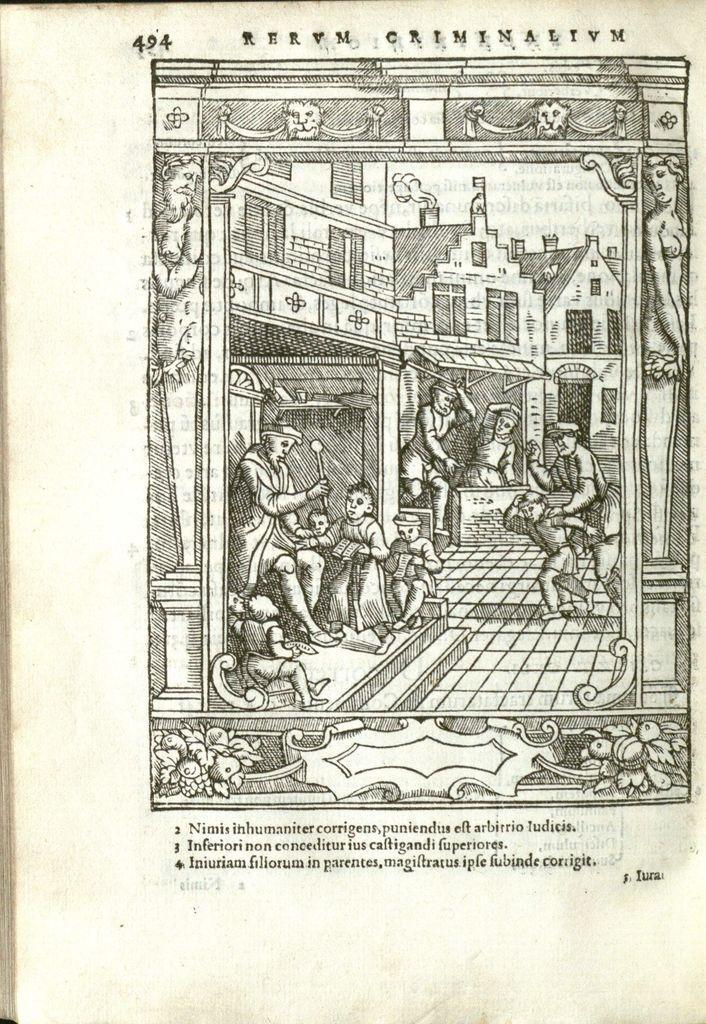Please provide a concise description of this image. In this image I can see a group of people on the floor, buildings, doors, windows, the sky, text. This image looks like a paper cutting of a book. 